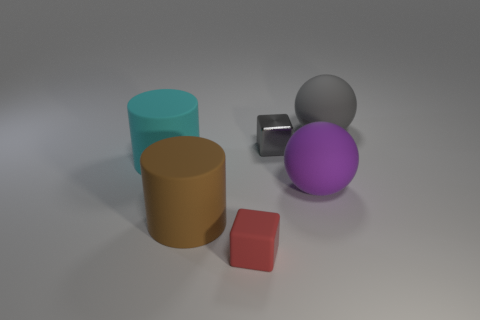How many other things are there of the same color as the small metallic block?
Make the answer very short. 1. There is a object that is the same color as the metallic cube; what is its size?
Offer a very short reply. Large. What number of things are large rubber objects that are to the right of the metallic cube or large red metallic cylinders?
Offer a very short reply. 2. Are there an equal number of shiny things behind the brown cylinder and brown rubber cubes?
Offer a terse response. No. Do the metallic block and the purple matte sphere have the same size?
Your answer should be very brief. No. There is a matte ball that is the same size as the purple rubber thing; what color is it?
Your answer should be very brief. Gray. Does the gray metallic thing have the same size as the matte ball to the left of the large gray ball?
Offer a very short reply. No. How many metal blocks have the same color as the matte block?
Offer a very short reply. 0. How many things are either large brown rubber things or matte things in front of the gray rubber ball?
Provide a short and direct response. 4. Do the rubber thing that is behind the small gray shiny cube and the matte cylinder to the right of the big cyan matte object have the same size?
Give a very brief answer. Yes. 